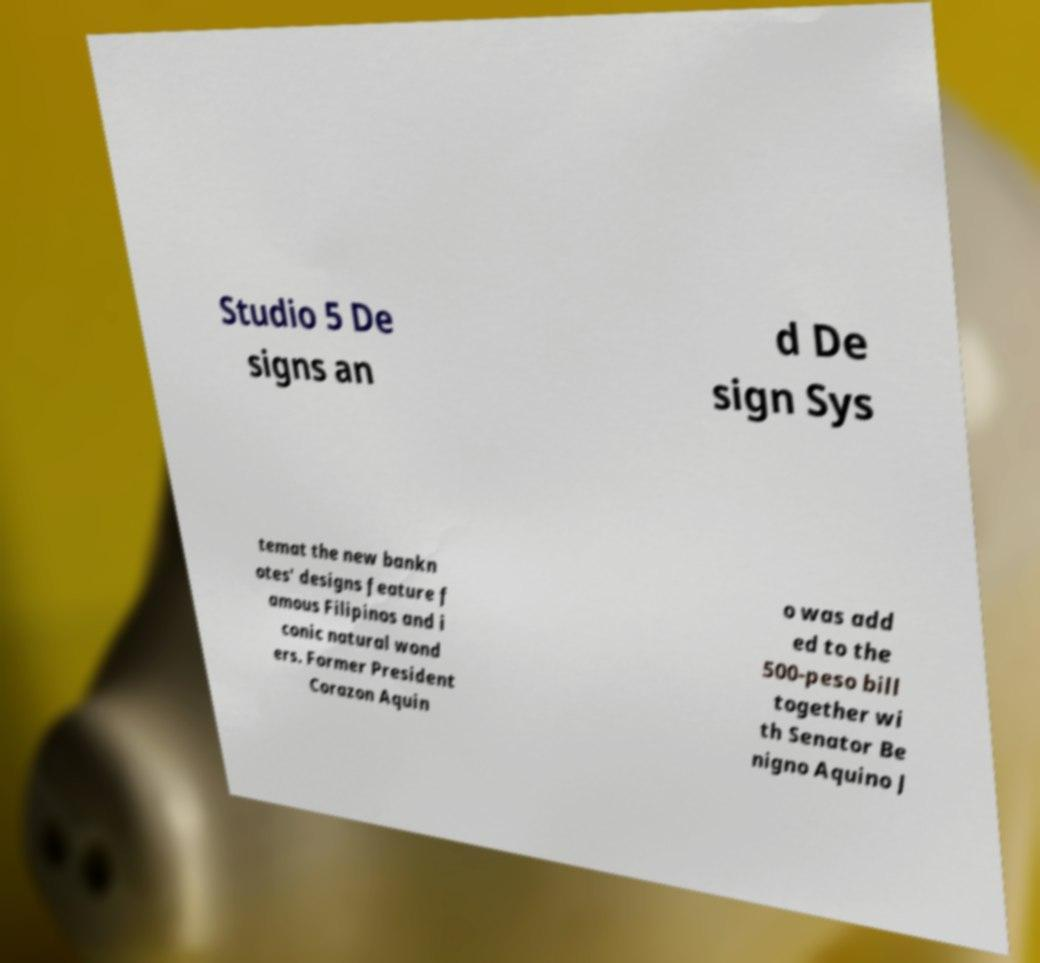What messages or text are displayed in this image? I need them in a readable, typed format. Studio 5 De signs an d De sign Sys temat the new bankn otes' designs feature f amous Filipinos and i conic natural wond ers. Former President Corazon Aquin o was add ed to the 500-peso bill together wi th Senator Be nigno Aquino J 